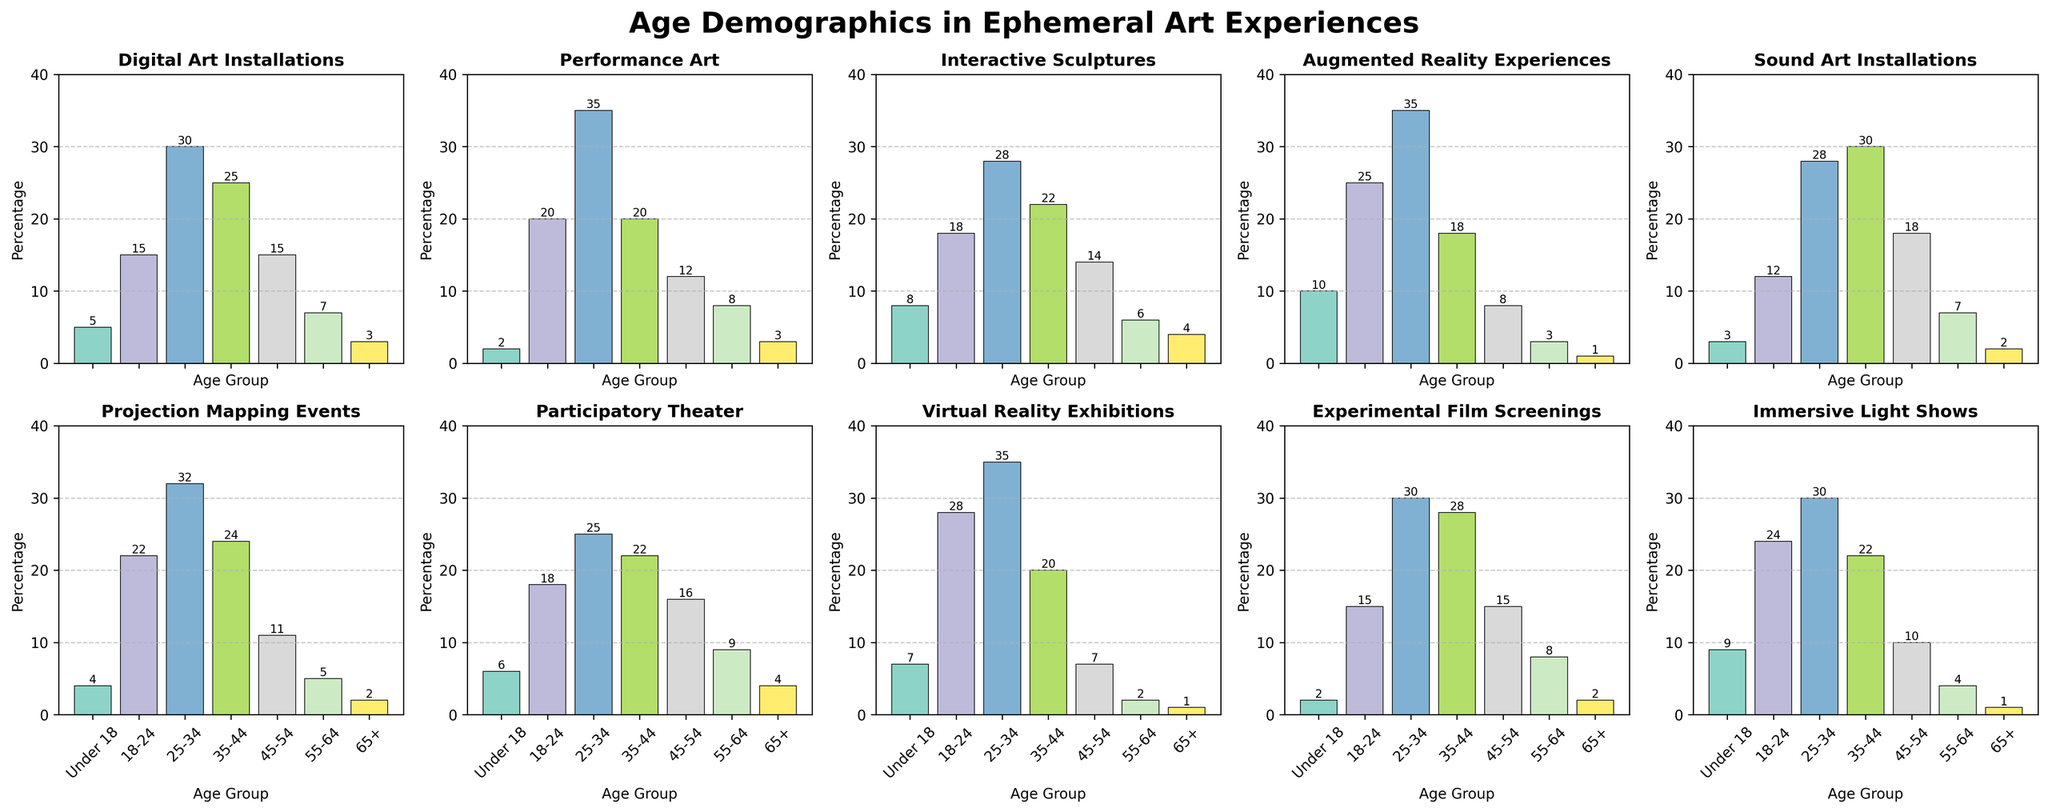Which age group participates the most in Experimental Film Screenings? The bar for the 25-34 age group is the tallest in the subplot for Experimental Film Screenings, indicating the highest participation, with the value of 30.
Answer: 25-34 How many participants aged 18-24 are involved in Digital Art Installations and Augmented Reality Experiences combined? The 18-24 age group has 15 participants for Digital Art Installations and 25 for Augmented Reality Experiences. Adding them together gives 15 + 25 = 40.
Answer: 40 Which artistic experience has more participants aged 45-54, Sound Art Installations or Participatory Theater? The bar for the 45-54 age group in the Sound Art Installations subplot is higher than in the Participatory Theater subplot, with values of 18 and 16 respectively.
Answer: Sound Art Installations Is the participation by the Under 18 age group higher in Interactive Sculptures or Performance Art? For Interactive Sculptures, the Under 18 age group has 8 participants. For Performance Art, the Under 18 age group has 2 participants. Therefore, Interactive Sculptures have higher Under 18 participation.
Answer: Interactive Sculptures Which age group has an equal number of participants in Performance Art and Augmented Reality Experiences? The 25-34 age group has the same height bars in both Performance Art and Augmented Reality Experiences, with the number being 35 participants.
Answer: 25-34 What is the total participation of the 65+ age group across all the given art forms? Adding the number of participants of the 65+ age group for all art forms: 3 (Digital Art Installations) + 3 (Performance Art) + 4 (Interactive Sculptures) + 1 (Augmented Reality Experiences) + 2 (Sound Art Installations) + 2 (Projection Mapping Events) + 4 (Participatory Theater) + 1 (Virtual Reality Exhibitions) + 2 (Experimental Film Screenings) + 1 (Immersive Light Shows) = 23.
Answer: 23 Which artistic experience has the least participation from the 55-64 age group? For the 55-64 age group, Augmented Reality Experiences have the lowest participation, with the value of 3, as seen from the shortest bar among the given subplots for this age group.
Answer: Augmented Reality Experiences In which artistic experience does the 35-44 age group participate the most? The highest bar for the 35-44 age group is in the Sound Art Installations subplot, with a value of 30 participants.
Answer: Sound Art Installations What is the range of participation values for the 18-24 age group across all art forms? The lowest participation value for the 18-24 age group is 12 (Sound Art Installations), and the highest is 28 (Virtual Reality Exhibitions). The range is 28 - 12 = 16.
Answer: 16 